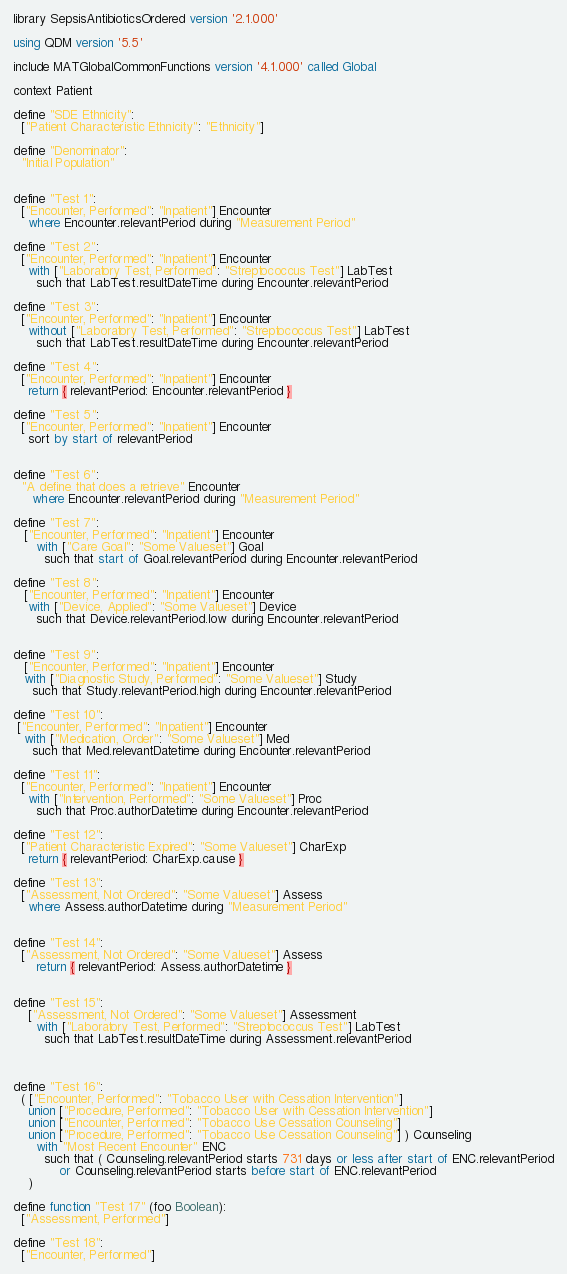<code> <loc_0><loc_0><loc_500><loc_500><_SQL_>library SepsisAntibioticsOrdered version '2.1.000'

using QDM version '5.5'

include MATGlobalCommonFunctions version '4.1.000' called Global

context Patient

define "SDE Ethnicity":
  ["Patient Characteristic Ethnicity": "Ethnicity"]

define "Denominator":
  "Initial Population"


define "Test 1":
  ["Encounter, Performed": "Inpatient"] Encounter
    where Encounter.relevantPeriod during "Measurement Period"

define "Test 2":
  ["Encounter, Performed": "Inpatient"] Encounter
    with ["Laboratory Test, Performed": "Streptococcus Test"] LabTest
      such that LabTest.resultDateTime during Encounter.relevantPeriod

define "Test 3":
  ["Encounter, Performed": "Inpatient"] Encounter
    without ["Laboratory Test, Performed": "Streptococcus Test"] LabTest
      such that LabTest.resultDateTime during Encounter.relevantPeriod

define "Test 4":
  ["Encounter, Performed": "Inpatient"] Encounter
    return { relevantPeriod: Encounter.relevantPeriod }

define "Test 5":
  ["Encounter, Performed": "Inpatient"] Encounter
    sort by start of relevantPeriod


define "Test 6":
  "A define that does a retrieve" Encounter
     where Encounter.relevantPeriod during "Measurement Period"

define "Test 7":
   ["Encounter, Performed": "Inpatient"] Encounter
      with ["Care Goal": "Some Valueset"] Goal
        such that start of Goal.relevantPeriod during Encounter.relevantPeriod

define "Test 8":
   ["Encounter, Performed": "Inpatient"] Encounter
    with ["Device, Applied": "Some Valueset"] Device
      such that Device.relevantPeriod.low during Encounter.relevantPeriod


define "Test 9":
   ["Encounter, Performed": "Inpatient"] Encounter
   with ["Diagnostic Study, Performed": "Some Valueset"] Study
     such that Study.relevantPeriod.high during Encounter.relevantPeriod

define "Test 10":
 ["Encounter, Performed": "Inpatient"] Encounter
   with ["Medication, Order": "Some Valueset"] Med
     such that Med.relevantDatetime during Encounter.relevantPeriod

define "Test 11":
  ["Encounter, Performed": "Inpatient"] Encounter
    with ["Intervention, Performed": "Some Valueset"] Proc
      such that Proc.authorDatetime during Encounter.relevantPeriod

define "Test 12":
  ["Patient Characteristic Expired": "Some Valueset"] CharExp
    return { relevantPeriod: CharExp.cause }

define "Test 13":
  ["Assessment, Not Ordered": "Some Valueset"] Assess
    where Assess.authorDatetime during "Measurement Period"


define "Test 14":
  ["Assessment, Not Ordered": "Some Valueset"] Assess
      return { relevantPeriod: Assess.authorDatetime }


define "Test 15":
    ["Assessment, Not Ordered": "Some Valueset"] Assessment
      with ["Laboratory Test, Performed": "Streptococcus Test"] LabTest
        such that LabTest.resultDateTime during Assessment.relevantPeriod



define "Test 16":
  ( ["Encounter, Performed": "Tobacco User with Cessation Intervention"]
    union ["Procedure, Performed": "Tobacco User with Cessation Intervention"]
    union ["Encounter, Performed": "Tobacco Use Cessation Counseling"]
    union ["Procedure, Performed": "Tobacco Use Cessation Counseling"] ) Counseling
      with "Most Recent Encounter" ENC
        such that ( Counseling.relevantPeriod starts 731 days or less after start of ENC.relevantPeriod
            or Counseling.relevantPeriod starts before start of ENC.relevantPeriod
    )

define function "Test 17" (foo Boolean):
  ["Assessment, Performed"]

define "Test 18":
  ["Encounter, Performed"]</code> 